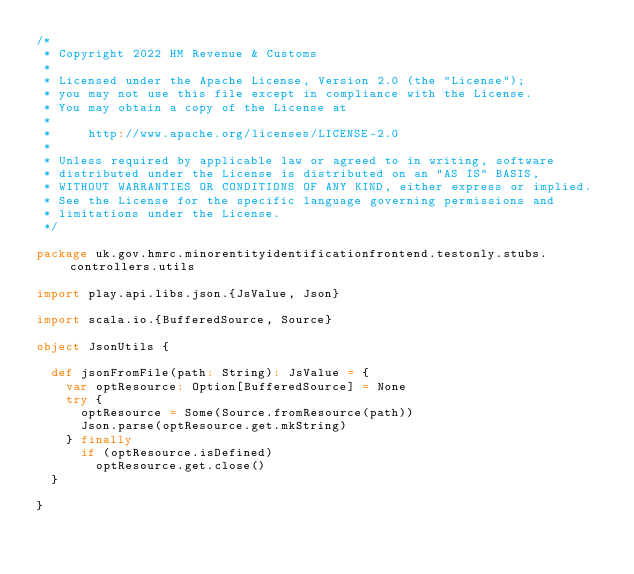<code> <loc_0><loc_0><loc_500><loc_500><_Scala_>/*
 * Copyright 2022 HM Revenue & Customs
 *
 * Licensed under the Apache License, Version 2.0 (the "License");
 * you may not use this file except in compliance with the License.
 * You may obtain a copy of the License at
 *
 *     http://www.apache.org/licenses/LICENSE-2.0
 *
 * Unless required by applicable law or agreed to in writing, software
 * distributed under the License is distributed on an "AS IS" BASIS,
 * WITHOUT WARRANTIES OR CONDITIONS OF ANY KIND, either express or implied.
 * See the License for the specific language governing permissions and
 * limitations under the License.
 */

package uk.gov.hmrc.minorentityidentificationfrontend.testonly.stubs.controllers.utils

import play.api.libs.json.{JsValue, Json}

import scala.io.{BufferedSource, Source}

object JsonUtils {

  def jsonFromFile(path: String): JsValue = {
    var optResource: Option[BufferedSource] = None
    try {
      optResource = Some(Source.fromResource(path))
      Json.parse(optResource.get.mkString)
    } finally
      if (optResource.isDefined)
        optResource.get.close()
  }

}
</code> 